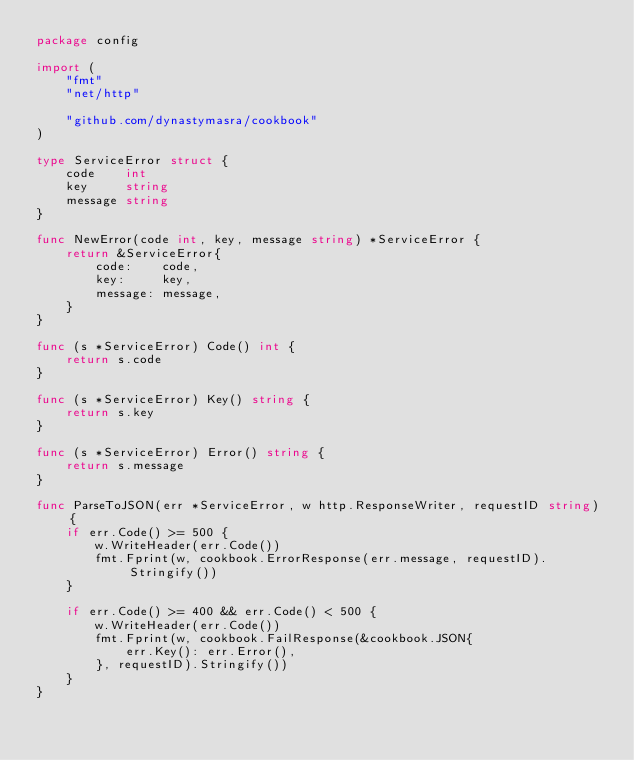<code> <loc_0><loc_0><loc_500><loc_500><_Go_>package config

import (
	"fmt"
	"net/http"

	"github.com/dynastymasra/cookbook"
)

type ServiceError struct {
	code    int
	key     string
	message string
}

func NewError(code int, key, message string) *ServiceError {
	return &ServiceError{
		code:    code,
		key:     key,
		message: message,
	}
}

func (s *ServiceError) Code() int {
	return s.code
}

func (s *ServiceError) Key() string {
	return s.key
}

func (s *ServiceError) Error() string {
	return s.message
}

func ParseToJSON(err *ServiceError, w http.ResponseWriter, requestID string) {
	if err.Code() >= 500 {
		w.WriteHeader(err.Code())
		fmt.Fprint(w, cookbook.ErrorResponse(err.message, requestID).Stringify())
	}

	if err.Code() >= 400 && err.Code() < 500 {
		w.WriteHeader(err.Code())
		fmt.Fprint(w, cookbook.FailResponse(&cookbook.JSON{
			err.Key(): err.Error(),
		}, requestID).Stringify())
	}
}
</code> 